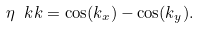<formula> <loc_0><loc_0><loc_500><loc_500>\eta _ { \ } k k = \cos ( k _ { x } ) - \cos ( k _ { y } ) .</formula> 